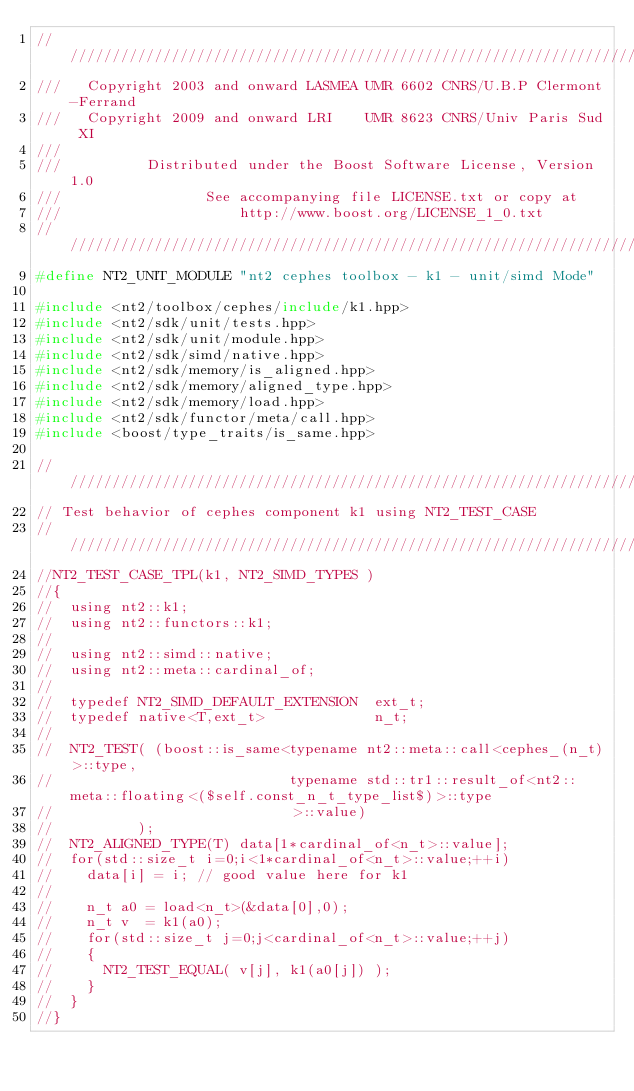Convert code to text. <code><loc_0><loc_0><loc_500><loc_500><_C++_>//////////////////////////////////////////////////////////////////////////////
///   Copyright 2003 and onward LASMEA UMR 6602 CNRS/U.B.P Clermont-Ferrand
///   Copyright 2009 and onward LRI    UMR 8623 CNRS/Univ Paris Sud XI
///
///          Distributed under the Boost Software License, Version 1.0
///                 See accompanying file LICENSE.txt or copy at
///                     http://www.boost.org/LICENSE_1_0.txt
//////////////////////////////////////////////////////////////////////////////
#define NT2_UNIT_MODULE "nt2 cephes toolbox - k1 - unit/simd Mode"

#include <nt2/toolbox/cephes/include/k1.hpp>
#include <nt2/sdk/unit/tests.hpp>
#include <nt2/sdk/unit/module.hpp>
#include <nt2/sdk/simd/native.hpp>
#include <nt2/sdk/memory/is_aligned.hpp>
#include <nt2/sdk/memory/aligned_type.hpp>
#include <nt2/sdk/memory/load.hpp>
#include <nt2/sdk/functor/meta/call.hpp>
#include <boost/type_traits/is_same.hpp>

//////////////////////////////////////////////////////////////////////////////
// Test behavior of cephes component k1 using NT2_TEST_CASE
//////////////////////////////////////////////////////////////////////////////
//NT2_TEST_CASE_TPL(k1, NT2_SIMD_TYPES )
//{
//  using nt2::k1;
//  using nt2::functors::k1;
// 
//  using nt2::simd::native;
//  using nt2::meta::cardinal_of;
//
//  typedef NT2_SIMD_DEFAULT_EXTENSION  ext_t;
//  typedef native<T,ext_t>             n_t;
//
//  NT2_TEST( (boost::is_same<typename nt2::meta::call<cephes_(n_t)>::type,
//                            typename std::tr1::result_of<nt2::meta::floating<($self.const_n_t_type_list$)>::type
//                            >::value)
//          );
//  NT2_ALIGNED_TYPE(T) data[1*cardinal_of<n_t>::value];
//  for(std::size_t i=0;i<1*cardinal_of<n_t>::value;++i)
//    data[i] = i; // good value here for k1
//
//    n_t a0 = load<n_t>(&data[0],0);
//    n_t v  = k1(a0);
//    for(std::size_t j=0;j<cardinal_of<n_t>::value;++j)
//    {
//      NT2_TEST_EQUAL( v[j], k1(a0[j]) );
//    }
//  }
//}

</code> 